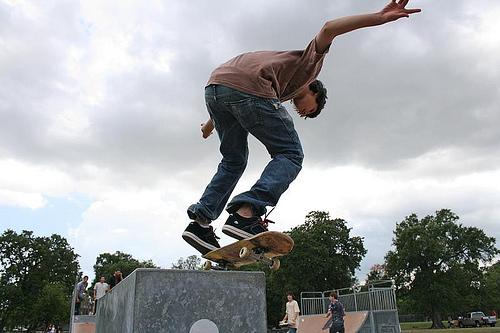What has wheels in the photo?
Keep it brief. Skateboard. How many boys are in the picture?
Write a very short answer. 6. Is there a large gray cloud in the sky?
Short answer required. Yes. 